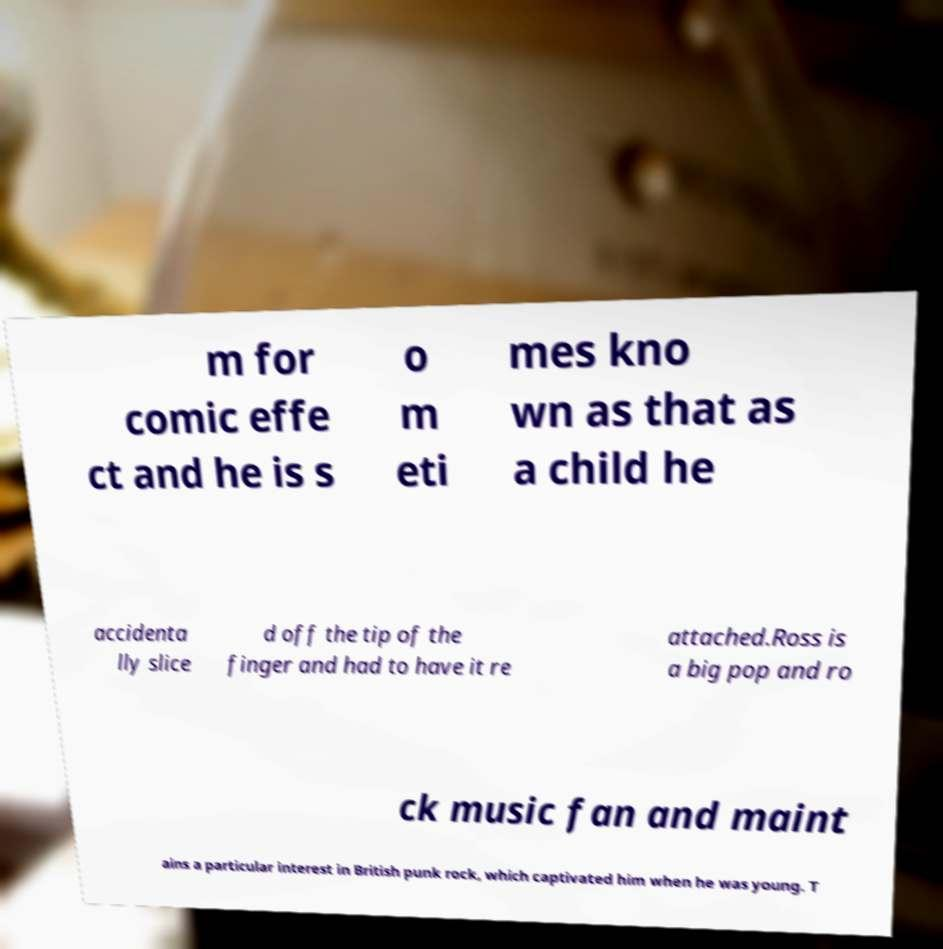Could you extract and type out the text from this image? m for comic effe ct and he is s o m eti mes kno wn as that as a child he accidenta lly slice d off the tip of the finger and had to have it re attached.Ross is a big pop and ro ck music fan and maint ains a particular interest in British punk rock, which captivated him when he was young. T 